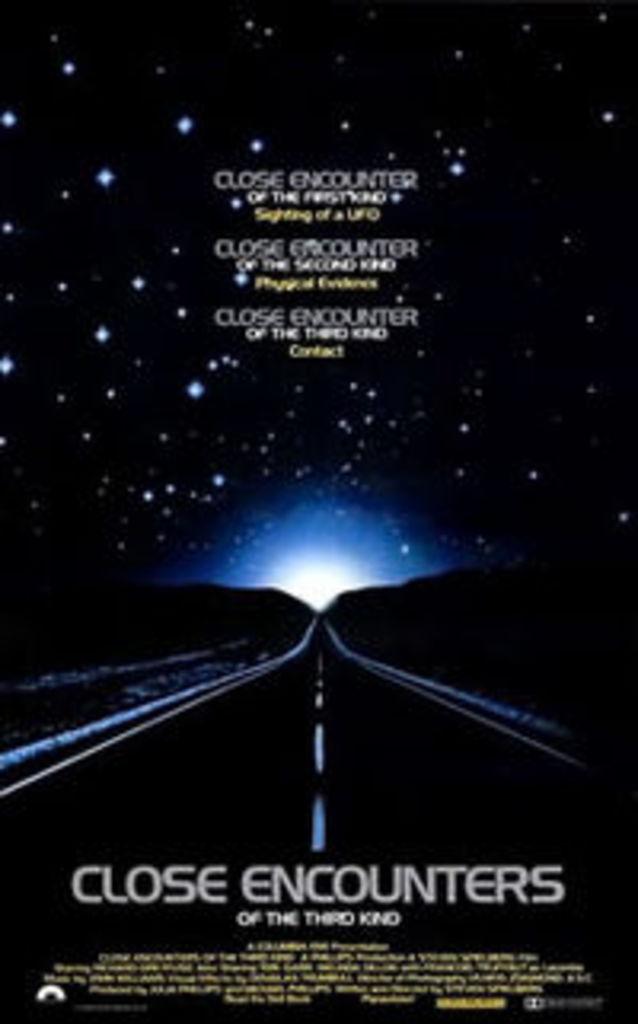What movie is this?
Your answer should be very brief. Close encounters. What movie is this?
Offer a terse response. Close encounters of the third kind. 